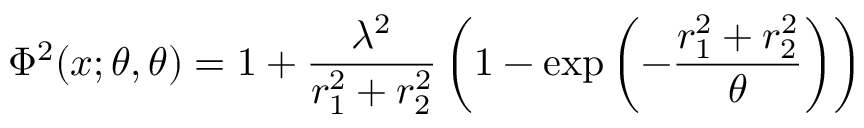Convert formula to latex. <formula><loc_0><loc_0><loc_500><loc_500>\Phi ^ { 2 } ( x ; \theta , \theta ) = 1 + \frac { \lambda ^ { 2 } } { r _ { 1 } ^ { 2 } + r _ { 2 } ^ { 2 } } \left ( 1 - \exp \left ( - \frac { r _ { 1 } ^ { 2 } + r _ { 2 } ^ { 2 } } { \theta } \right ) \right )</formula> 